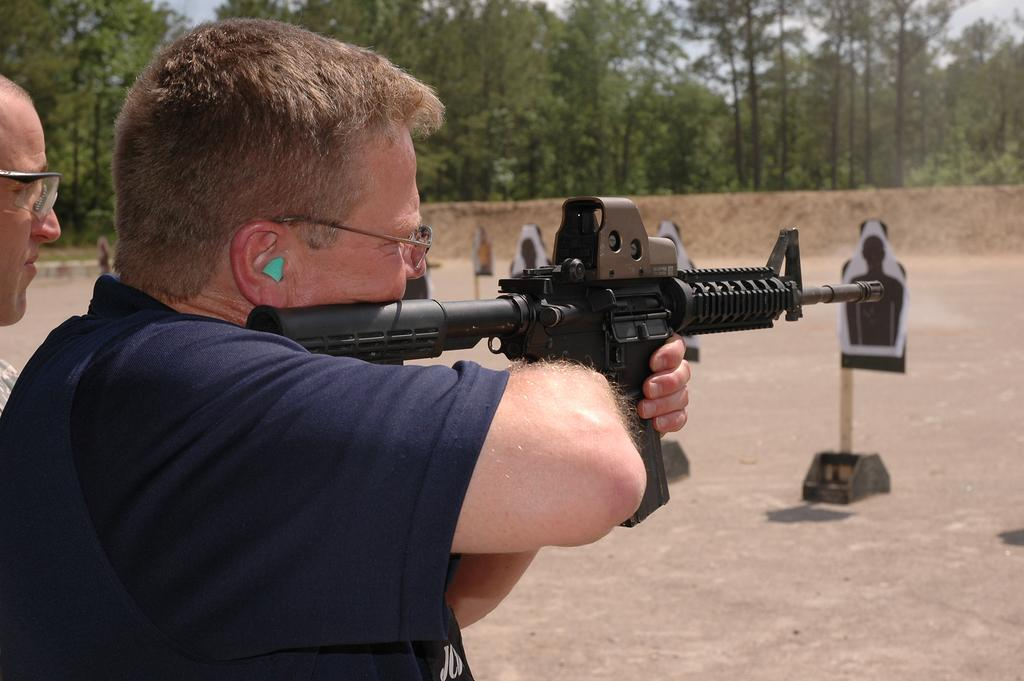What is the main subject of the image? There is a person standing in the image. What is the person holding? The person is holding a gun. What is in front of the person holding the gun? There are boards in front of the person. Is there anyone else in the image? Yes, there is another man next to the person holding the gun. What can be seen in the background of the image? There are trees and the sky visible in the background of the image. What type of crops are being grown in the field behind the person holding the gun? There is no field or crops visible in the image; it features a person holding a gun with boards in front of them, another man next to them, and trees and the sky in the background. 